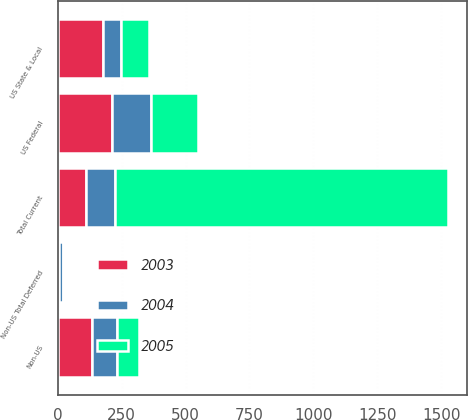Convert chart. <chart><loc_0><loc_0><loc_500><loc_500><stacked_bar_chart><ecel><fcel>US State & Local<fcel>Non-US<fcel>Total Current<fcel>US Federal<fcel>Non-US Total Deferred<nl><fcel>2003<fcel>176<fcel>135<fcel>112<fcel>211<fcel>6<nl><fcel>2004<fcel>71<fcel>98<fcel>112<fcel>155<fcel>16<nl><fcel>2005<fcel>112<fcel>86<fcel>1301<fcel>181<fcel>1<nl></chart> 